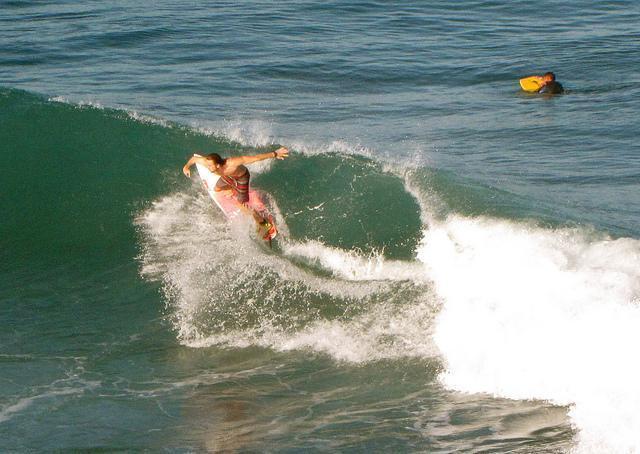How many people?
Give a very brief answer. 2. 